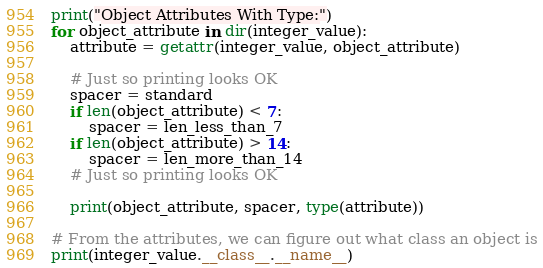Convert code to text. <code><loc_0><loc_0><loc_500><loc_500><_Python_>
print("Object Attributes With Type:")
for object_attribute in dir(integer_value):
    attribute = getattr(integer_value, object_attribute)

    # Just so printing looks OK
    spacer = standard
    if len(object_attribute) < 7:
        spacer = len_less_than_7
    if len(object_attribute) > 14:
        spacer = len_more_than_14
    # Just so printing looks OK

    print(object_attribute, spacer, type(attribute))

# From the attributes, we can figure out what class an object is
print(integer_value.__class__.__name__)</code> 